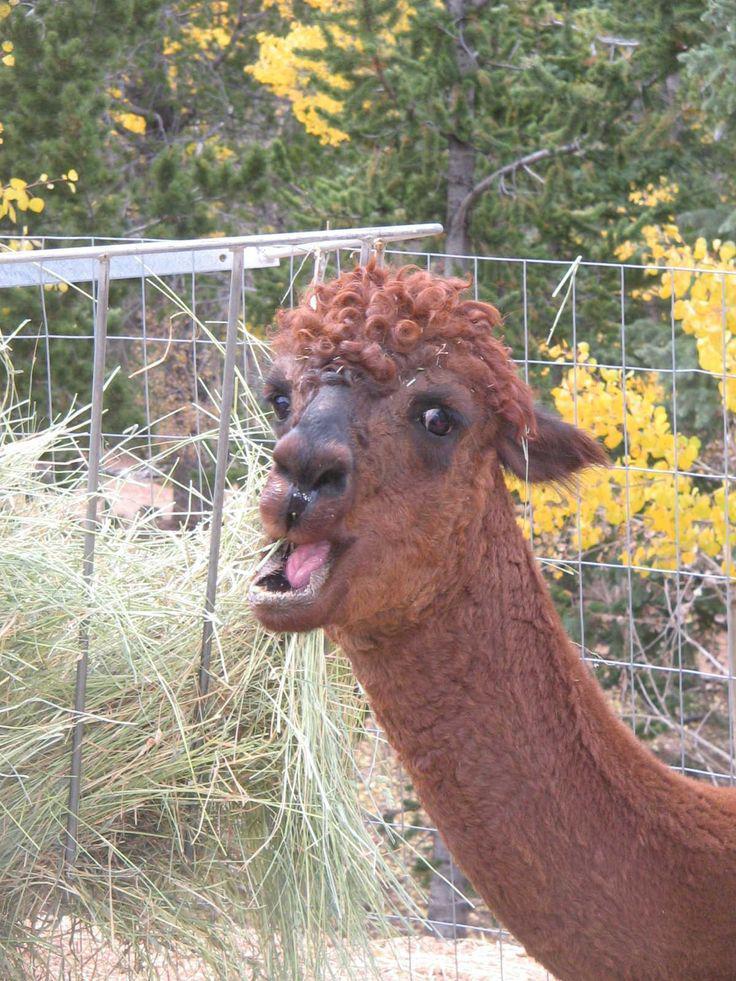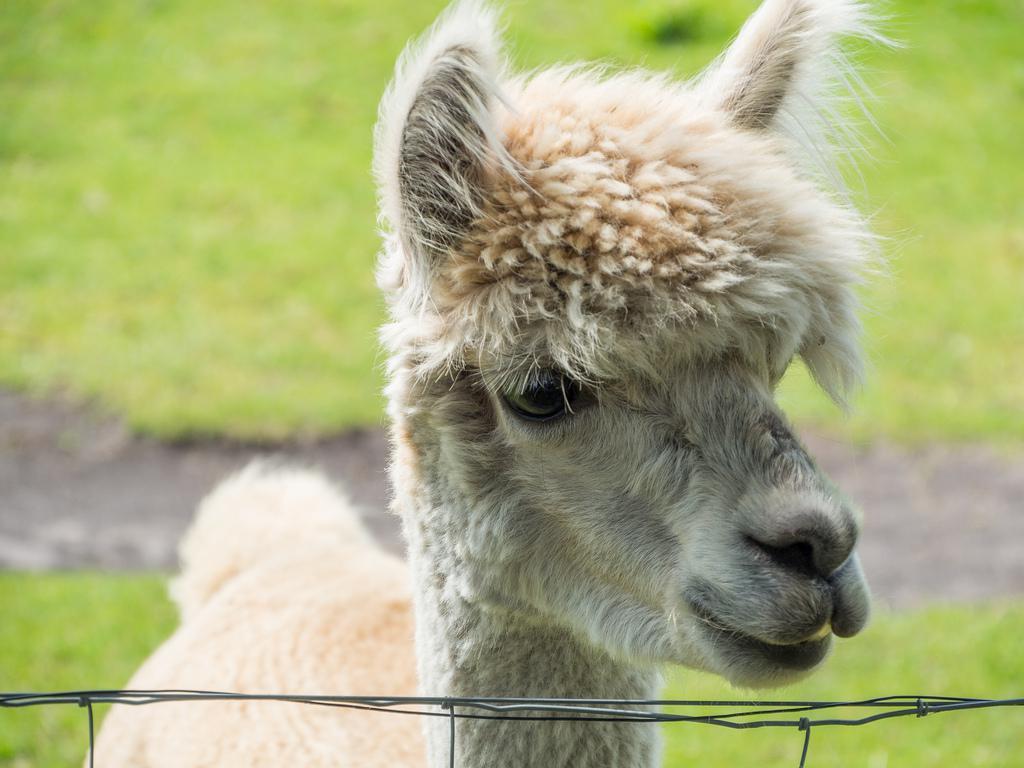The first image is the image on the left, the second image is the image on the right. Analyze the images presented: Is the assertion "The head of one llama can seen in each image and none of them have brown fur." valid? Answer yes or no. No. The first image is the image on the left, the second image is the image on the right. Evaluate the accuracy of this statement regarding the images: "Four llama eyes are visible.". Is it true? Answer yes or no. No. 